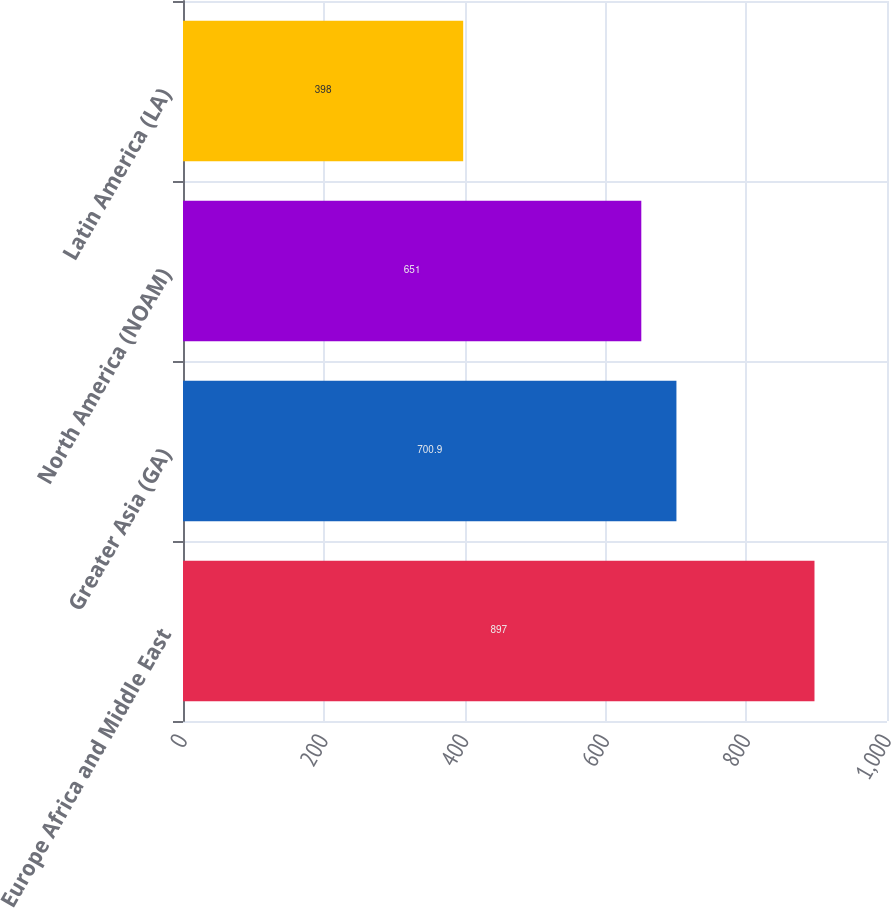Convert chart to OTSL. <chart><loc_0><loc_0><loc_500><loc_500><bar_chart><fcel>Europe Africa and Middle East<fcel>Greater Asia (GA)<fcel>North America (NOAM)<fcel>Latin America (LA)<nl><fcel>897<fcel>700.9<fcel>651<fcel>398<nl></chart> 